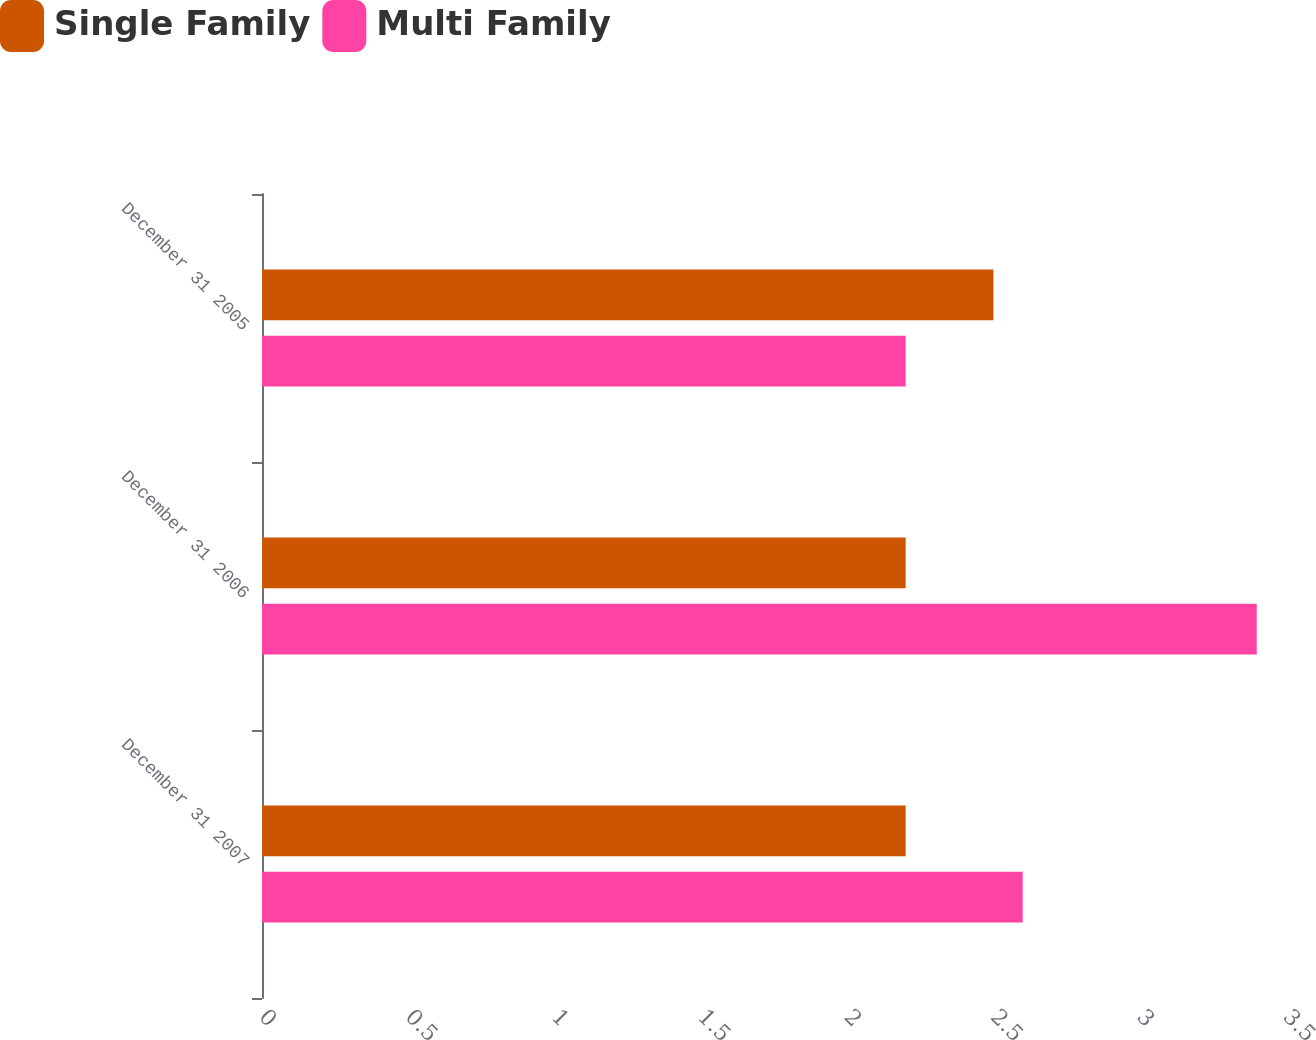Convert chart. <chart><loc_0><loc_0><loc_500><loc_500><stacked_bar_chart><ecel><fcel>December 31 2007<fcel>December 31 2006<fcel>December 31 2005<nl><fcel>Single Family<fcel>2.2<fcel>2.2<fcel>2.5<nl><fcel>Multi Family<fcel>2.6<fcel>3.4<fcel>2.2<nl></chart> 